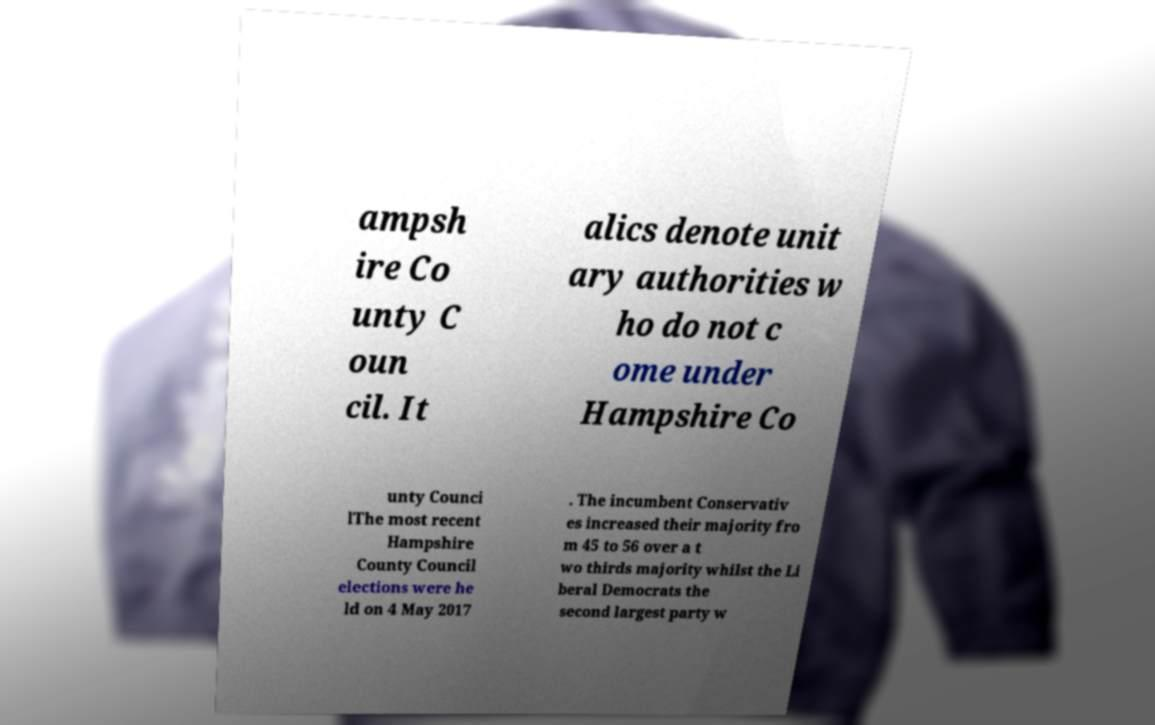Could you extract and type out the text from this image? ampsh ire Co unty C oun cil. It alics denote unit ary authorities w ho do not c ome under Hampshire Co unty Counci lThe most recent Hampshire County Council elections were he ld on 4 May 2017 . The incumbent Conservativ es increased their majority fro m 45 to 56 over a t wo thirds majority whilst the Li beral Democrats the second largest party w 